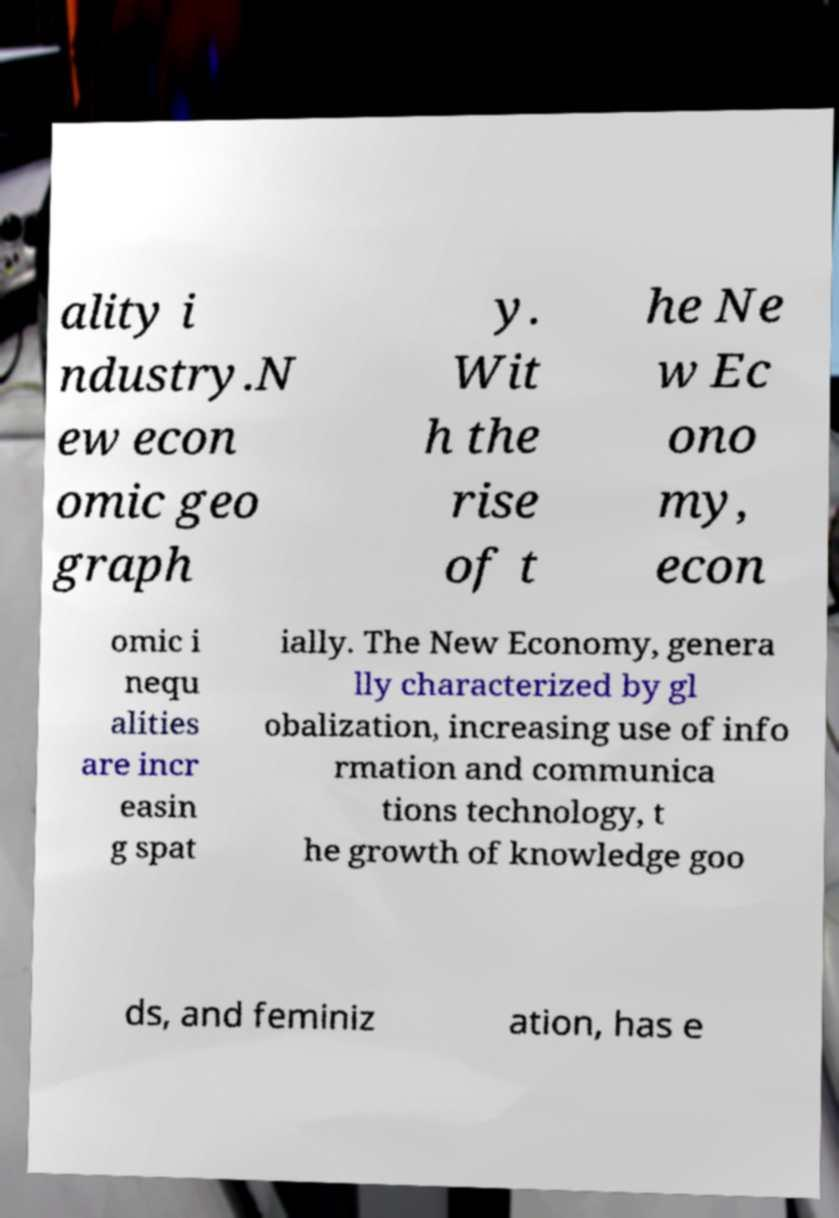Please read and relay the text visible in this image. What does it say? ality i ndustry.N ew econ omic geo graph y. Wit h the rise of t he Ne w Ec ono my, econ omic i nequ alities are incr easin g spat ially. The New Economy, genera lly characterized by gl obalization, increasing use of info rmation and communica tions technology, t he growth of knowledge goo ds, and feminiz ation, has e 